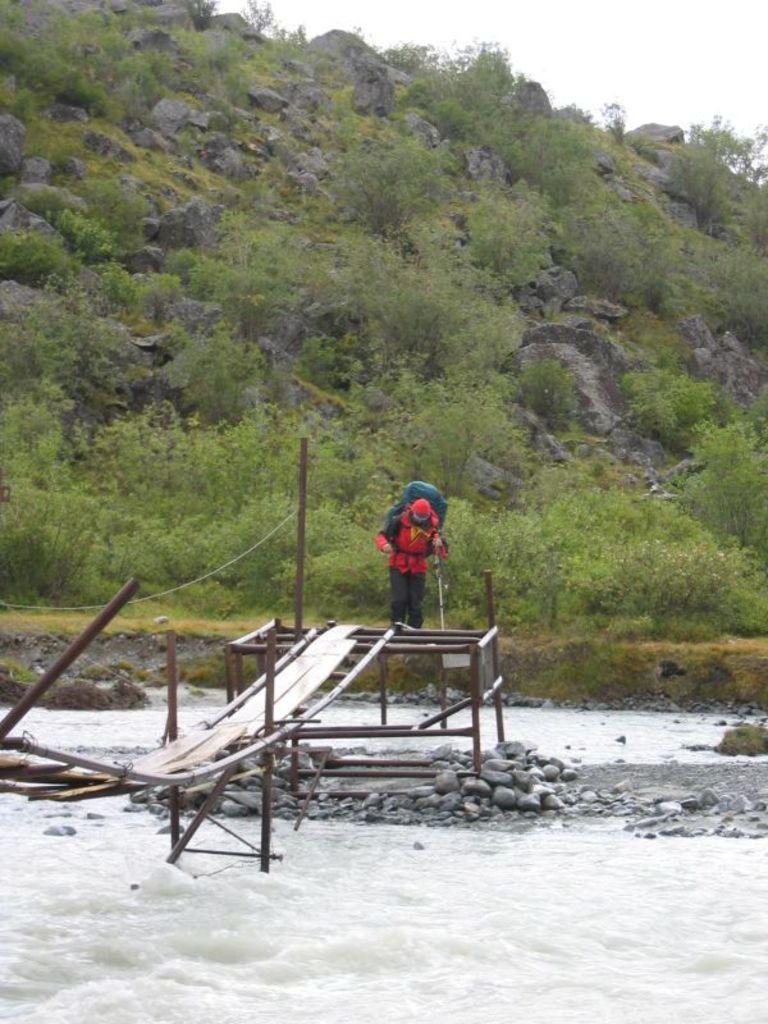Please provide a concise description of this image. In this image there is the sky, there are rocks, there are trees, there is a river, there is a bridge, there is a person standing on the surface, there is a person holding an object, there are stones, there are plants. 